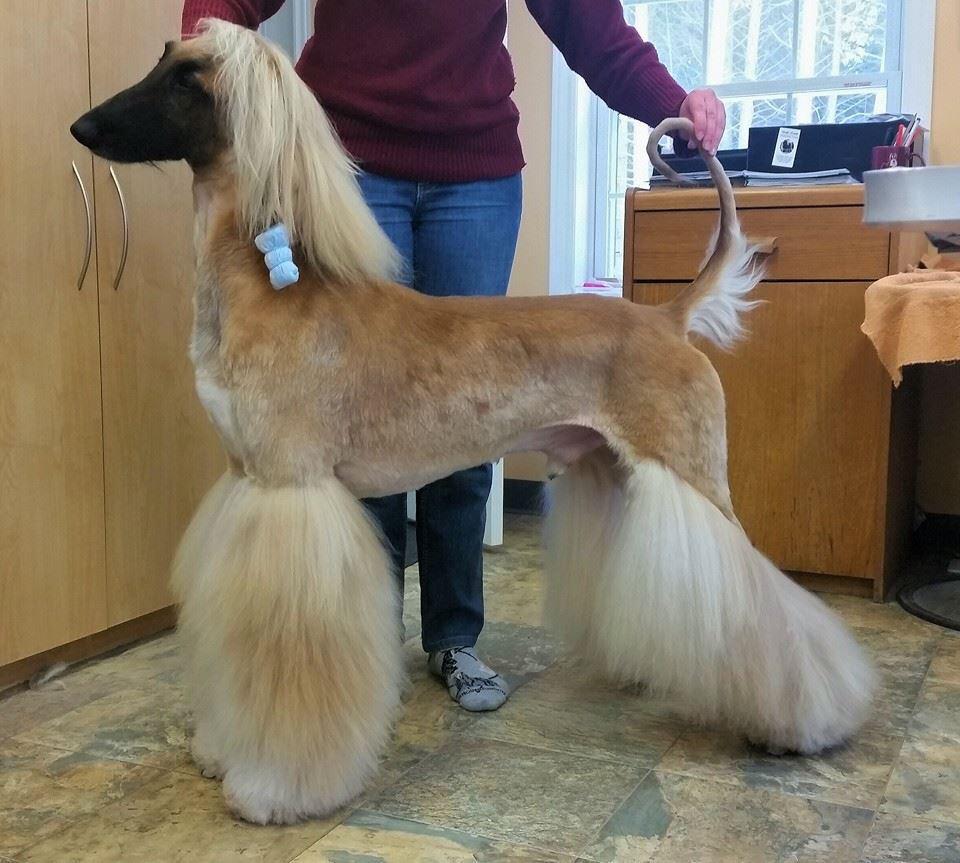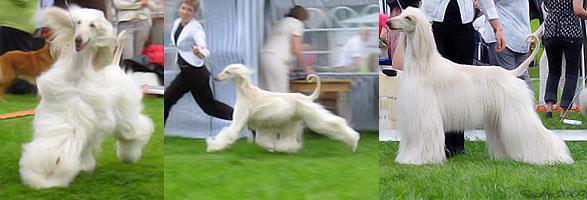The first image is the image on the left, the second image is the image on the right. Considering the images on both sides, is "There are four dogs in total." valid? Answer yes or no. Yes. 